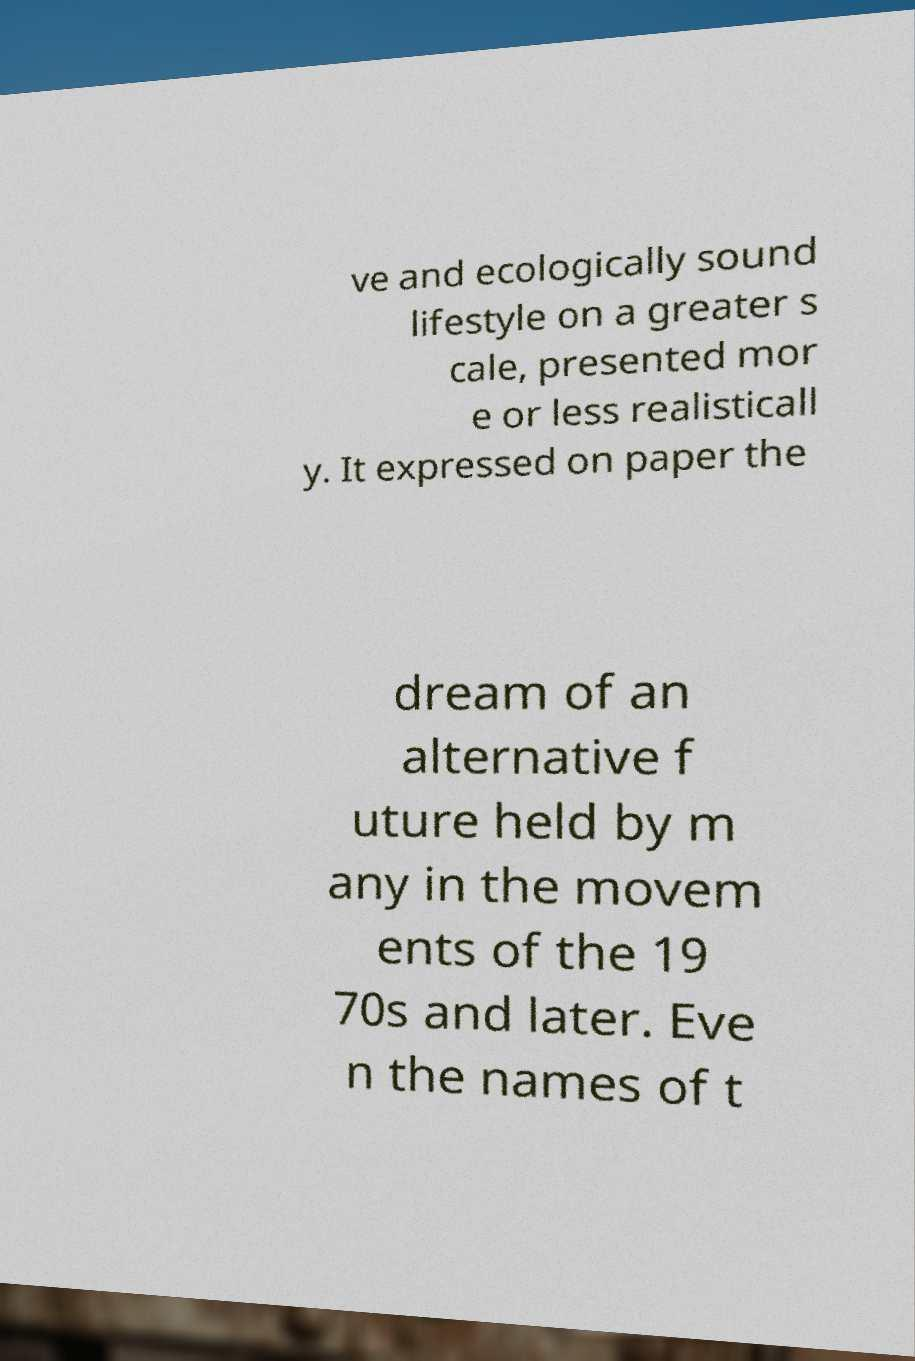Please identify and transcribe the text found in this image. ve and ecologically sound lifestyle on a greater s cale, presented mor e or less realisticall y. It expressed on paper the dream of an alternative f uture held by m any in the movem ents of the 19 70s and later. Eve n the names of t 